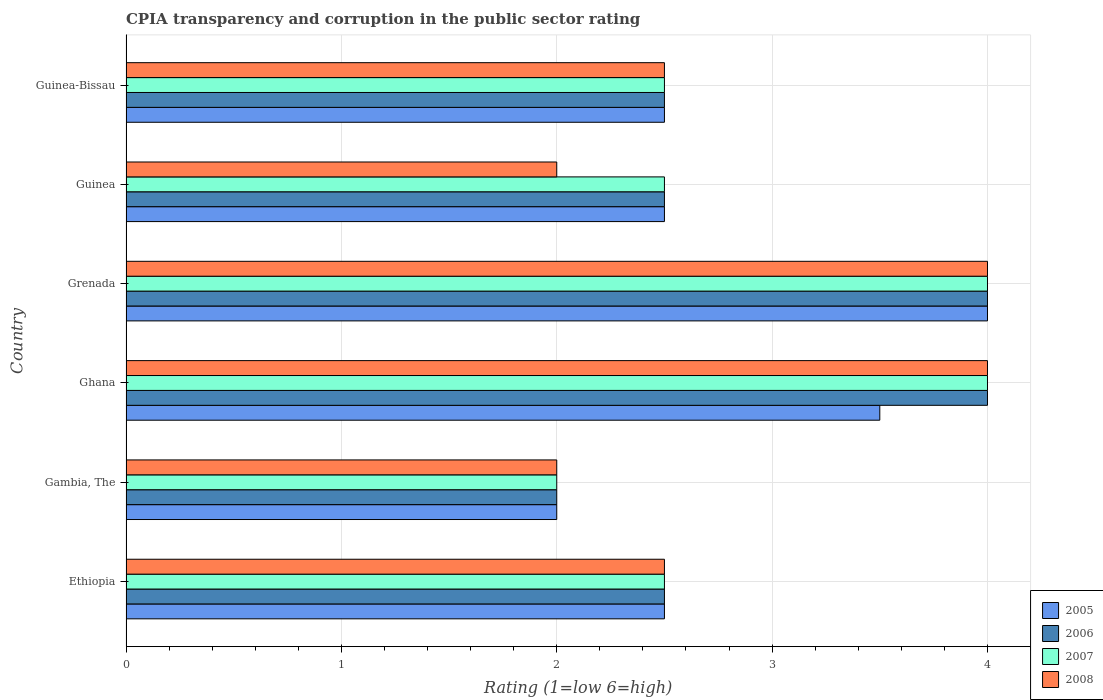How many different coloured bars are there?
Your answer should be compact. 4. How many groups of bars are there?
Your response must be concise. 6. Are the number of bars on each tick of the Y-axis equal?
Offer a terse response. Yes. What is the label of the 2nd group of bars from the top?
Offer a very short reply. Guinea. Across all countries, what is the maximum CPIA rating in 2006?
Provide a short and direct response. 4. Across all countries, what is the minimum CPIA rating in 2006?
Your answer should be compact. 2. In which country was the CPIA rating in 2007 maximum?
Your answer should be compact. Ghana. In which country was the CPIA rating in 2005 minimum?
Your response must be concise. Gambia, The. What is the difference between the CPIA rating in 2006 in Guinea-Bissau and the CPIA rating in 2007 in Gambia, The?
Ensure brevity in your answer.  0.5. What is the average CPIA rating in 2008 per country?
Ensure brevity in your answer.  2.83. What is the difference between the highest and the second highest CPIA rating in 2005?
Give a very brief answer. 0.5. What is the difference between the highest and the lowest CPIA rating in 2006?
Your response must be concise. 2. What does the 2nd bar from the bottom in Ethiopia represents?
Your response must be concise. 2006. How many bars are there?
Make the answer very short. 24. Are all the bars in the graph horizontal?
Keep it short and to the point. Yes. What is the difference between two consecutive major ticks on the X-axis?
Give a very brief answer. 1. Are the values on the major ticks of X-axis written in scientific E-notation?
Keep it short and to the point. No. Does the graph contain any zero values?
Your answer should be compact. No. Does the graph contain grids?
Ensure brevity in your answer.  Yes. Where does the legend appear in the graph?
Offer a very short reply. Bottom right. How many legend labels are there?
Provide a succinct answer. 4. What is the title of the graph?
Your answer should be very brief. CPIA transparency and corruption in the public sector rating. What is the label or title of the X-axis?
Make the answer very short. Rating (1=low 6=high). What is the Rating (1=low 6=high) in 2005 in Ethiopia?
Provide a short and direct response. 2.5. What is the Rating (1=low 6=high) in 2006 in Gambia, The?
Give a very brief answer. 2. What is the Rating (1=low 6=high) of 2007 in Gambia, The?
Make the answer very short. 2. What is the Rating (1=low 6=high) in 2005 in Ghana?
Your answer should be very brief. 3.5. What is the Rating (1=low 6=high) of 2006 in Ghana?
Make the answer very short. 4. What is the Rating (1=low 6=high) of 2007 in Ghana?
Make the answer very short. 4. What is the Rating (1=low 6=high) of 2005 in Grenada?
Give a very brief answer. 4. What is the Rating (1=low 6=high) of 2006 in Grenada?
Ensure brevity in your answer.  4. What is the Rating (1=low 6=high) of 2007 in Grenada?
Provide a short and direct response. 4. What is the Rating (1=low 6=high) in 2006 in Guinea?
Make the answer very short. 2.5. What is the Rating (1=low 6=high) in 2008 in Guinea?
Your answer should be very brief. 2. Across all countries, what is the maximum Rating (1=low 6=high) of 2008?
Provide a short and direct response. 4. Across all countries, what is the minimum Rating (1=low 6=high) in 2005?
Ensure brevity in your answer.  2. Across all countries, what is the minimum Rating (1=low 6=high) of 2006?
Your answer should be very brief. 2. Across all countries, what is the minimum Rating (1=low 6=high) in 2007?
Offer a terse response. 2. What is the total Rating (1=low 6=high) in 2005 in the graph?
Give a very brief answer. 17. What is the total Rating (1=low 6=high) in 2007 in the graph?
Your answer should be compact. 17.5. What is the total Rating (1=low 6=high) of 2008 in the graph?
Give a very brief answer. 17. What is the difference between the Rating (1=low 6=high) of 2005 in Ethiopia and that in Gambia, The?
Your response must be concise. 0.5. What is the difference between the Rating (1=low 6=high) of 2007 in Ethiopia and that in Gambia, The?
Your answer should be very brief. 0.5. What is the difference between the Rating (1=low 6=high) of 2008 in Ethiopia and that in Gambia, The?
Offer a terse response. 0.5. What is the difference between the Rating (1=low 6=high) of 2005 in Ethiopia and that in Ghana?
Provide a short and direct response. -1. What is the difference between the Rating (1=low 6=high) of 2006 in Ethiopia and that in Grenada?
Your answer should be very brief. -1.5. What is the difference between the Rating (1=low 6=high) of 2007 in Ethiopia and that in Grenada?
Provide a short and direct response. -1.5. What is the difference between the Rating (1=low 6=high) of 2008 in Ethiopia and that in Grenada?
Offer a terse response. -1.5. What is the difference between the Rating (1=low 6=high) in 2005 in Ethiopia and that in Guinea?
Keep it short and to the point. 0. What is the difference between the Rating (1=low 6=high) of 2006 in Ethiopia and that in Guinea?
Provide a succinct answer. 0. What is the difference between the Rating (1=low 6=high) of 2007 in Ethiopia and that in Guinea?
Provide a succinct answer. 0. What is the difference between the Rating (1=low 6=high) in 2005 in Ethiopia and that in Guinea-Bissau?
Ensure brevity in your answer.  0. What is the difference between the Rating (1=low 6=high) in 2006 in Gambia, The and that in Ghana?
Make the answer very short. -2. What is the difference between the Rating (1=low 6=high) in 2005 in Gambia, The and that in Grenada?
Provide a succinct answer. -2. What is the difference between the Rating (1=low 6=high) in 2007 in Gambia, The and that in Grenada?
Your answer should be very brief. -2. What is the difference between the Rating (1=low 6=high) in 2005 in Gambia, The and that in Guinea?
Give a very brief answer. -0.5. What is the difference between the Rating (1=low 6=high) in 2008 in Gambia, The and that in Guinea?
Give a very brief answer. 0. What is the difference between the Rating (1=low 6=high) in 2005 in Gambia, The and that in Guinea-Bissau?
Provide a short and direct response. -0.5. What is the difference between the Rating (1=low 6=high) in 2007 in Ghana and that in Grenada?
Your answer should be compact. 0. What is the difference between the Rating (1=low 6=high) in 2005 in Ghana and that in Guinea?
Provide a short and direct response. 1. What is the difference between the Rating (1=low 6=high) of 2006 in Ghana and that in Guinea?
Make the answer very short. 1.5. What is the difference between the Rating (1=low 6=high) of 2006 in Ghana and that in Guinea-Bissau?
Provide a short and direct response. 1.5. What is the difference between the Rating (1=low 6=high) of 2008 in Ghana and that in Guinea-Bissau?
Ensure brevity in your answer.  1.5. What is the difference between the Rating (1=low 6=high) of 2006 in Grenada and that in Guinea?
Your answer should be compact. 1.5. What is the difference between the Rating (1=low 6=high) of 2007 in Grenada and that in Guinea?
Your answer should be compact. 1.5. What is the difference between the Rating (1=low 6=high) in 2008 in Grenada and that in Guinea?
Make the answer very short. 2. What is the difference between the Rating (1=low 6=high) in 2005 in Grenada and that in Guinea-Bissau?
Your answer should be compact. 1.5. What is the difference between the Rating (1=low 6=high) in 2006 in Grenada and that in Guinea-Bissau?
Your response must be concise. 1.5. What is the difference between the Rating (1=low 6=high) of 2008 in Grenada and that in Guinea-Bissau?
Your answer should be compact. 1.5. What is the difference between the Rating (1=low 6=high) of 2005 in Ethiopia and the Rating (1=low 6=high) of 2006 in Gambia, The?
Keep it short and to the point. 0.5. What is the difference between the Rating (1=low 6=high) of 2005 in Ethiopia and the Rating (1=low 6=high) of 2007 in Gambia, The?
Make the answer very short. 0.5. What is the difference between the Rating (1=low 6=high) in 2005 in Ethiopia and the Rating (1=low 6=high) in 2008 in Gambia, The?
Your response must be concise. 0.5. What is the difference between the Rating (1=low 6=high) of 2006 in Ethiopia and the Rating (1=low 6=high) of 2007 in Gambia, The?
Your answer should be very brief. 0.5. What is the difference between the Rating (1=low 6=high) in 2005 in Ethiopia and the Rating (1=low 6=high) in 2007 in Ghana?
Provide a succinct answer. -1.5. What is the difference between the Rating (1=low 6=high) in 2005 in Ethiopia and the Rating (1=low 6=high) in 2008 in Ghana?
Ensure brevity in your answer.  -1.5. What is the difference between the Rating (1=low 6=high) in 2006 in Ethiopia and the Rating (1=low 6=high) in 2007 in Ghana?
Offer a terse response. -1.5. What is the difference between the Rating (1=low 6=high) in 2005 in Ethiopia and the Rating (1=low 6=high) in 2007 in Grenada?
Give a very brief answer. -1.5. What is the difference between the Rating (1=low 6=high) in 2005 in Ethiopia and the Rating (1=low 6=high) in 2008 in Guinea?
Make the answer very short. 0.5. What is the difference between the Rating (1=low 6=high) in 2006 in Ethiopia and the Rating (1=low 6=high) in 2007 in Guinea?
Keep it short and to the point. 0. What is the difference between the Rating (1=low 6=high) of 2005 in Ethiopia and the Rating (1=low 6=high) of 2006 in Guinea-Bissau?
Keep it short and to the point. 0. What is the difference between the Rating (1=low 6=high) of 2005 in Ethiopia and the Rating (1=low 6=high) of 2007 in Guinea-Bissau?
Your answer should be compact. 0. What is the difference between the Rating (1=low 6=high) in 2005 in Ethiopia and the Rating (1=low 6=high) in 2008 in Guinea-Bissau?
Your answer should be very brief. 0. What is the difference between the Rating (1=low 6=high) in 2006 in Ethiopia and the Rating (1=low 6=high) in 2007 in Guinea-Bissau?
Keep it short and to the point. 0. What is the difference between the Rating (1=low 6=high) of 2007 in Ethiopia and the Rating (1=low 6=high) of 2008 in Guinea-Bissau?
Give a very brief answer. 0. What is the difference between the Rating (1=low 6=high) in 2005 in Gambia, The and the Rating (1=low 6=high) in 2008 in Ghana?
Your answer should be very brief. -2. What is the difference between the Rating (1=low 6=high) of 2006 in Gambia, The and the Rating (1=low 6=high) of 2007 in Ghana?
Your answer should be compact. -2. What is the difference between the Rating (1=low 6=high) of 2006 in Gambia, The and the Rating (1=low 6=high) of 2008 in Ghana?
Your answer should be very brief. -2. What is the difference between the Rating (1=low 6=high) in 2005 in Gambia, The and the Rating (1=low 6=high) in 2007 in Grenada?
Provide a short and direct response. -2. What is the difference between the Rating (1=low 6=high) in 2006 in Gambia, The and the Rating (1=low 6=high) in 2008 in Grenada?
Make the answer very short. -2. What is the difference between the Rating (1=low 6=high) of 2007 in Gambia, The and the Rating (1=low 6=high) of 2008 in Grenada?
Ensure brevity in your answer.  -2. What is the difference between the Rating (1=low 6=high) in 2005 in Gambia, The and the Rating (1=low 6=high) in 2006 in Guinea?
Keep it short and to the point. -0.5. What is the difference between the Rating (1=low 6=high) of 2006 in Gambia, The and the Rating (1=low 6=high) of 2007 in Guinea?
Offer a terse response. -0.5. What is the difference between the Rating (1=low 6=high) of 2006 in Gambia, The and the Rating (1=low 6=high) of 2008 in Guinea?
Your answer should be compact. 0. What is the difference between the Rating (1=low 6=high) in 2005 in Gambia, The and the Rating (1=low 6=high) in 2007 in Guinea-Bissau?
Offer a very short reply. -0.5. What is the difference between the Rating (1=low 6=high) of 2006 in Gambia, The and the Rating (1=low 6=high) of 2007 in Guinea-Bissau?
Your answer should be very brief. -0.5. What is the difference between the Rating (1=low 6=high) in 2006 in Gambia, The and the Rating (1=low 6=high) in 2008 in Guinea-Bissau?
Provide a succinct answer. -0.5. What is the difference between the Rating (1=low 6=high) of 2005 in Ghana and the Rating (1=low 6=high) of 2007 in Grenada?
Provide a succinct answer. -0.5. What is the difference between the Rating (1=low 6=high) of 2005 in Ghana and the Rating (1=low 6=high) of 2008 in Grenada?
Your response must be concise. -0.5. What is the difference between the Rating (1=low 6=high) of 2006 in Ghana and the Rating (1=low 6=high) of 2007 in Grenada?
Give a very brief answer. 0. What is the difference between the Rating (1=low 6=high) of 2007 in Ghana and the Rating (1=low 6=high) of 2008 in Grenada?
Make the answer very short. 0. What is the difference between the Rating (1=low 6=high) of 2005 in Ghana and the Rating (1=low 6=high) of 2007 in Guinea?
Your response must be concise. 1. What is the difference between the Rating (1=low 6=high) in 2006 in Ghana and the Rating (1=low 6=high) in 2007 in Guinea?
Offer a terse response. 1.5. What is the difference between the Rating (1=low 6=high) of 2006 in Ghana and the Rating (1=low 6=high) of 2008 in Guinea?
Make the answer very short. 2. What is the difference between the Rating (1=low 6=high) in 2007 in Ghana and the Rating (1=low 6=high) in 2008 in Guinea?
Offer a very short reply. 2. What is the difference between the Rating (1=low 6=high) in 2007 in Ghana and the Rating (1=low 6=high) in 2008 in Guinea-Bissau?
Make the answer very short. 1.5. What is the difference between the Rating (1=low 6=high) of 2005 in Grenada and the Rating (1=low 6=high) of 2006 in Guinea?
Ensure brevity in your answer.  1.5. What is the difference between the Rating (1=low 6=high) in 2005 in Grenada and the Rating (1=low 6=high) in 2007 in Guinea?
Provide a succinct answer. 1.5. What is the difference between the Rating (1=low 6=high) in 2006 in Grenada and the Rating (1=low 6=high) in 2007 in Guinea?
Provide a succinct answer. 1.5. What is the difference between the Rating (1=low 6=high) of 2006 in Grenada and the Rating (1=low 6=high) of 2008 in Guinea?
Ensure brevity in your answer.  2. What is the difference between the Rating (1=low 6=high) in 2005 in Grenada and the Rating (1=low 6=high) in 2007 in Guinea-Bissau?
Your answer should be very brief. 1.5. What is the difference between the Rating (1=low 6=high) of 2005 in Grenada and the Rating (1=low 6=high) of 2008 in Guinea-Bissau?
Your answer should be very brief. 1.5. What is the difference between the Rating (1=low 6=high) in 2006 in Grenada and the Rating (1=low 6=high) in 2008 in Guinea-Bissau?
Offer a very short reply. 1.5. What is the difference between the Rating (1=low 6=high) of 2007 in Grenada and the Rating (1=low 6=high) of 2008 in Guinea-Bissau?
Provide a succinct answer. 1.5. What is the difference between the Rating (1=low 6=high) in 2005 in Guinea and the Rating (1=low 6=high) in 2006 in Guinea-Bissau?
Your answer should be very brief. 0. What is the average Rating (1=low 6=high) of 2005 per country?
Offer a very short reply. 2.83. What is the average Rating (1=low 6=high) of 2006 per country?
Offer a very short reply. 2.92. What is the average Rating (1=low 6=high) in 2007 per country?
Ensure brevity in your answer.  2.92. What is the average Rating (1=low 6=high) in 2008 per country?
Offer a terse response. 2.83. What is the difference between the Rating (1=low 6=high) in 2005 and Rating (1=low 6=high) in 2007 in Ethiopia?
Your response must be concise. 0. What is the difference between the Rating (1=low 6=high) in 2005 and Rating (1=low 6=high) in 2008 in Ethiopia?
Offer a very short reply. 0. What is the difference between the Rating (1=low 6=high) of 2005 and Rating (1=low 6=high) of 2006 in Gambia, The?
Your answer should be very brief. 0. What is the difference between the Rating (1=low 6=high) in 2005 and Rating (1=low 6=high) in 2007 in Gambia, The?
Provide a succinct answer. 0. What is the difference between the Rating (1=low 6=high) of 2005 and Rating (1=low 6=high) of 2008 in Gambia, The?
Offer a terse response. 0. What is the difference between the Rating (1=low 6=high) of 2007 and Rating (1=low 6=high) of 2008 in Gambia, The?
Ensure brevity in your answer.  0. What is the difference between the Rating (1=low 6=high) of 2005 and Rating (1=low 6=high) of 2006 in Ghana?
Offer a very short reply. -0.5. What is the difference between the Rating (1=low 6=high) of 2006 and Rating (1=low 6=high) of 2007 in Ghana?
Make the answer very short. 0. What is the difference between the Rating (1=low 6=high) in 2006 and Rating (1=low 6=high) in 2008 in Ghana?
Provide a succinct answer. 0. What is the difference between the Rating (1=low 6=high) of 2005 and Rating (1=low 6=high) of 2007 in Grenada?
Make the answer very short. 0. What is the difference between the Rating (1=low 6=high) in 2005 and Rating (1=low 6=high) in 2008 in Grenada?
Give a very brief answer. 0. What is the difference between the Rating (1=low 6=high) of 2006 and Rating (1=low 6=high) of 2007 in Grenada?
Provide a short and direct response. 0. What is the difference between the Rating (1=low 6=high) in 2007 and Rating (1=low 6=high) in 2008 in Grenada?
Your answer should be very brief. 0. What is the difference between the Rating (1=low 6=high) of 2005 and Rating (1=low 6=high) of 2007 in Guinea?
Keep it short and to the point. 0. What is the difference between the Rating (1=low 6=high) in 2005 and Rating (1=low 6=high) in 2008 in Guinea?
Offer a very short reply. 0.5. What is the difference between the Rating (1=low 6=high) of 2006 and Rating (1=low 6=high) of 2007 in Guinea?
Make the answer very short. 0. What is the difference between the Rating (1=low 6=high) in 2006 and Rating (1=low 6=high) in 2008 in Guinea?
Provide a succinct answer. 0.5. What is the difference between the Rating (1=low 6=high) in 2005 and Rating (1=low 6=high) in 2008 in Guinea-Bissau?
Your answer should be compact. 0. What is the difference between the Rating (1=low 6=high) in 2006 and Rating (1=low 6=high) in 2007 in Guinea-Bissau?
Provide a short and direct response. 0. What is the difference between the Rating (1=low 6=high) in 2006 and Rating (1=low 6=high) in 2008 in Guinea-Bissau?
Your answer should be compact. 0. What is the ratio of the Rating (1=low 6=high) in 2007 in Ethiopia to that in Gambia, The?
Offer a terse response. 1.25. What is the ratio of the Rating (1=low 6=high) of 2006 in Ethiopia to that in Ghana?
Keep it short and to the point. 0.62. What is the ratio of the Rating (1=low 6=high) in 2005 in Ethiopia to that in Grenada?
Your answer should be compact. 0.62. What is the ratio of the Rating (1=low 6=high) in 2007 in Ethiopia to that in Grenada?
Your response must be concise. 0.62. What is the ratio of the Rating (1=low 6=high) of 2008 in Ethiopia to that in Grenada?
Make the answer very short. 0.62. What is the ratio of the Rating (1=low 6=high) in 2005 in Ethiopia to that in Guinea?
Ensure brevity in your answer.  1. What is the ratio of the Rating (1=low 6=high) of 2006 in Ethiopia to that in Guinea?
Your answer should be very brief. 1. What is the ratio of the Rating (1=low 6=high) of 2006 in Ethiopia to that in Guinea-Bissau?
Provide a succinct answer. 1. What is the ratio of the Rating (1=low 6=high) of 2006 in Gambia, The to that in Ghana?
Offer a terse response. 0.5. What is the ratio of the Rating (1=low 6=high) in 2007 in Gambia, The to that in Ghana?
Offer a very short reply. 0.5. What is the ratio of the Rating (1=low 6=high) in 2006 in Gambia, The to that in Grenada?
Provide a succinct answer. 0.5. What is the ratio of the Rating (1=low 6=high) in 2008 in Gambia, The to that in Grenada?
Give a very brief answer. 0.5. What is the ratio of the Rating (1=low 6=high) in 2005 in Gambia, The to that in Guinea?
Ensure brevity in your answer.  0.8. What is the ratio of the Rating (1=low 6=high) of 2007 in Gambia, The to that in Guinea?
Keep it short and to the point. 0.8. What is the ratio of the Rating (1=low 6=high) in 2008 in Gambia, The to that in Guinea?
Your response must be concise. 1. What is the ratio of the Rating (1=low 6=high) in 2005 in Gambia, The to that in Guinea-Bissau?
Provide a short and direct response. 0.8. What is the ratio of the Rating (1=low 6=high) of 2006 in Gambia, The to that in Guinea-Bissau?
Provide a short and direct response. 0.8. What is the ratio of the Rating (1=low 6=high) in 2008 in Gambia, The to that in Guinea-Bissau?
Keep it short and to the point. 0.8. What is the ratio of the Rating (1=low 6=high) in 2005 in Ghana to that in Grenada?
Offer a very short reply. 0.88. What is the ratio of the Rating (1=low 6=high) of 2006 in Ghana to that in Grenada?
Your response must be concise. 1. What is the ratio of the Rating (1=low 6=high) of 2008 in Ghana to that in Grenada?
Your response must be concise. 1. What is the ratio of the Rating (1=low 6=high) of 2006 in Ghana to that in Guinea?
Provide a succinct answer. 1.6. What is the ratio of the Rating (1=low 6=high) of 2008 in Ghana to that in Guinea?
Offer a very short reply. 2. What is the ratio of the Rating (1=low 6=high) in 2006 in Ghana to that in Guinea-Bissau?
Make the answer very short. 1.6. What is the ratio of the Rating (1=low 6=high) in 2005 in Grenada to that in Guinea?
Give a very brief answer. 1.6. What is the ratio of the Rating (1=low 6=high) in 2007 in Grenada to that in Guinea?
Offer a terse response. 1.6. What is the ratio of the Rating (1=low 6=high) of 2005 in Grenada to that in Guinea-Bissau?
Provide a succinct answer. 1.6. What is the ratio of the Rating (1=low 6=high) of 2006 in Grenada to that in Guinea-Bissau?
Offer a terse response. 1.6. What is the ratio of the Rating (1=low 6=high) of 2008 in Grenada to that in Guinea-Bissau?
Keep it short and to the point. 1.6. What is the ratio of the Rating (1=low 6=high) in 2005 in Guinea to that in Guinea-Bissau?
Ensure brevity in your answer.  1. What is the ratio of the Rating (1=low 6=high) in 2007 in Guinea to that in Guinea-Bissau?
Make the answer very short. 1. What is the difference between the highest and the second highest Rating (1=low 6=high) in 2005?
Your response must be concise. 0.5. What is the difference between the highest and the second highest Rating (1=low 6=high) in 2006?
Provide a short and direct response. 0. What is the difference between the highest and the second highest Rating (1=low 6=high) in 2008?
Your answer should be compact. 0. What is the difference between the highest and the lowest Rating (1=low 6=high) in 2005?
Make the answer very short. 2. What is the difference between the highest and the lowest Rating (1=low 6=high) of 2008?
Keep it short and to the point. 2. 